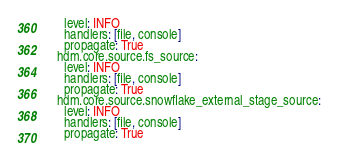Convert code to text. <code><loc_0><loc_0><loc_500><loc_500><_YAML_>    level: INFO
    handlers: [file, console]
    propagate: True
  hdm.core.source.fs_source:
    level: INFO
    handlers: [file, console]
    propagate: True
  hdm.core.source.snowflake_external_stage_source:
    level: INFO
    handlers: [file, console]
    propagate: True</code> 